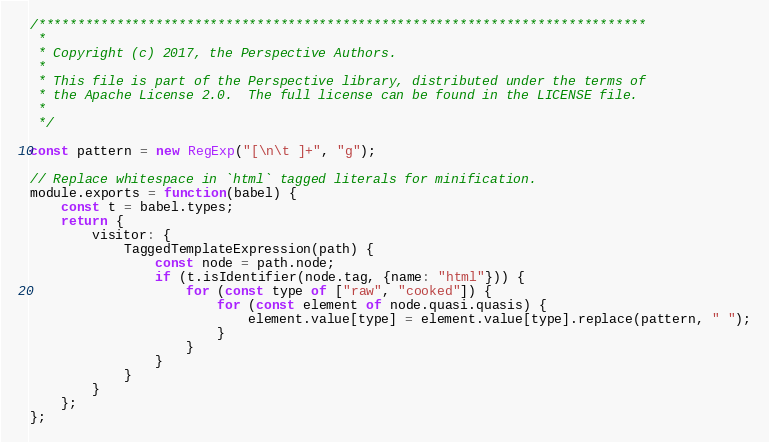<code> <loc_0><loc_0><loc_500><loc_500><_JavaScript_>/******************************************************************************
 *
 * Copyright (c) 2017, the Perspective Authors.
 *
 * This file is part of the Perspective library, distributed under the terms of
 * the Apache License 2.0.  The full license can be found in the LICENSE file.
 *
 */

const pattern = new RegExp("[\n\t ]+", "g");

// Replace whitespace in `html` tagged literals for minification.
module.exports = function(babel) {
    const t = babel.types;
    return {
        visitor: {
            TaggedTemplateExpression(path) {
                const node = path.node;
                if (t.isIdentifier(node.tag, {name: "html"})) {
                    for (const type of ["raw", "cooked"]) {
                        for (const element of node.quasi.quasis) {
                            element.value[type] = element.value[type].replace(pattern, " ");
                        }
                    }
                }
            }
        }
    };
};
</code> 